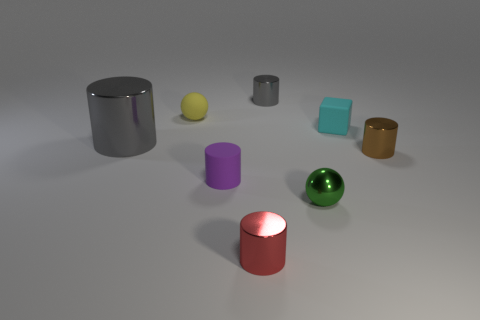Does the yellow matte object have the same shape as the matte thing that is to the right of the green shiny ball?
Make the answer very short. No. There is a gray cylinder behind the matte object behind the cyan thing; is there a small cyan rubber cube on the left side of it?
Offer a very short reply. No. The red shiny thing has what size?
Offer a very short reply. Small. How many other things are there of the same color as the large shiny thing?
Give a very brief answer. 1. There is a shiny thing that is left of the small yellow matte thing; is its shape the same as the cyan rubber object?
Your response must be concise. No. There is a tiny rubber object that is the same shape as the red metallic thing; what is its color?
Ensure brevity in your answer.  Purple. Are there any other things that have the same material as the small cyan object?
Your response must be concise. Yes. There is a brown shiny thing that is the same shape as the purple thing; what size is it?
Offer a terse response. Small. There is a thing that is both in front of the cube and on the left side of the purple rubber thing; what material is it?
Your answer should be compact. Metal. There is a matte object that is on the right side of the purple matte thing; does it have the same color as the rubber sphere?
Make the answer very short. No. 